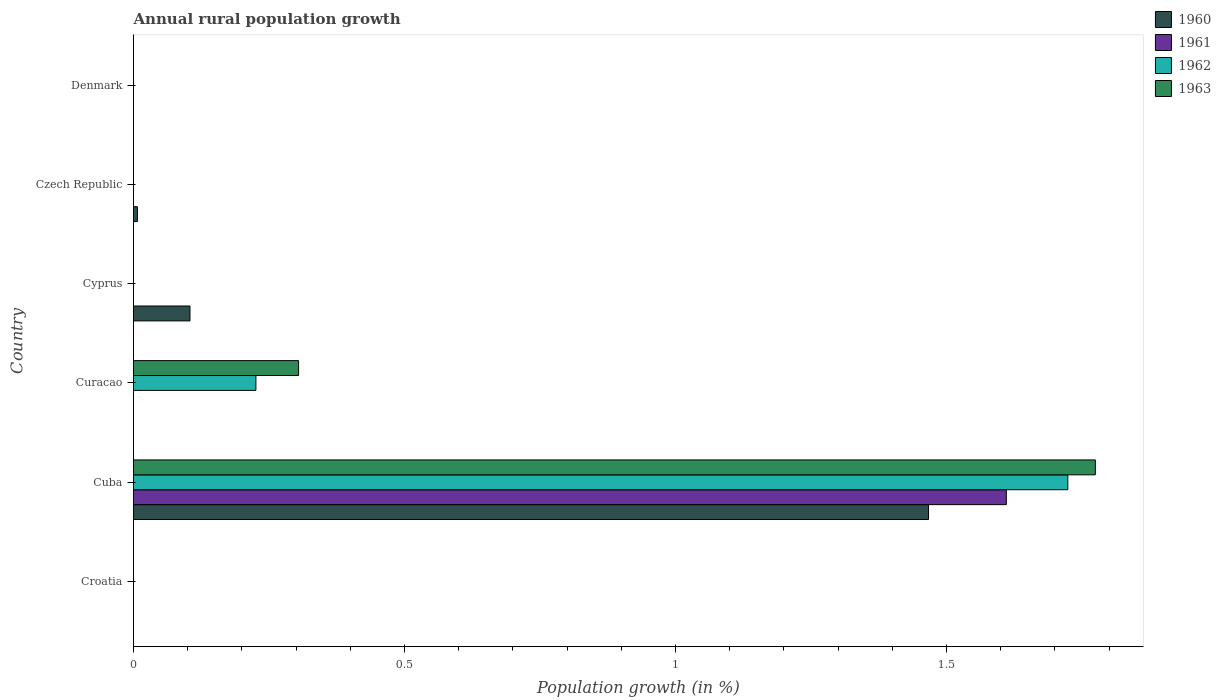How many different coloured bars are there?
Give a very brief answer. 4. How many bars are there on the 6th tick from the top?
Give a very brief answer. 0. What is the label of the 1st group of bars from the top?
Offer a terse response. Denmark. Across all countries, what is the maximum percentage of rural population growth in 1962?
Give a very brief answer. 1.72. Across all countries, what is the minimum percentage of rural population growth in 1960?
Your response must be concise. 0. In which country was the percentage of rural population growth in 1960 maximum?
Ensure brevity in your answer.  Cuba. What is the total percentage of rural population growth in 1962 in the graph?
Offer a terse response. 1.95. What is the difference between the percentage of rural population growth in 1961 in Czech Republic and the percentage of rural population growth in 1962 in Cuba?
Provide a succinct answer. -1.72. What is the average percentage of rural population growth in 1960 per country?
Your answer should be compact. 0.26. What is the difference between the percentage of rural population growth in 1962 and percentage of rural population growth in 1961 in Cuba?
Give a very brief answer. 0.11. In how many countries, is the percentage of rural population growth in 1963 greater than 1 %?
Your response must be concise. 1. What is the ratio of the percentage of rural population growth in 1962 in Cuba to that in Curacao?
Your answer should be very brief. 7.63. What is the difference between the highest and the lowest percentage of rural population growth in 1962?
Provide a succinct answer. 1.72. How many countries are there in the graph?
Provide a short and direct response. 6. What is the difference between two consecutive major ticks on the X-axis?
Give a very brief answer. 0.5. Does the graph contain any zero values?
Your answer should be very brief. Yes. Does the graph contain grids?
Your answer should be compact. No. How are the legend labels stacked?
Provide a short and direct response. Vertical. What is the title of the graph?
Your response must be concise. Annual rural population growth. Does "2001" appear as one of the legend labels in the graph?
Your response must be concise. No. What is the label or title of the X-axis?
Provide a short and direct response. Population growth (in %). What is the Population growth (in %) of 1961 in Croatia?
Provide a succinct answer. 0. What is the Population growth (in %) of 1963 in Croatia?
Give a very brief answer. 0. What is the Population growth (in %) of 1960 in Cuba?
Provide a short and direct response. 1.47. What is the Population growth (in %) of 1961 in Cuba?
Your answer should be very brief. 1.61. What is the Population growth (in %) of 1962 in Cuba?
Offer a very short reply. 1.72. What is the Population growth (in %) in 1963 in Cuba?
Ensure brevity in your answer.  1.77. What is the Population growth (in %) in 1961 in Curacao?
Ensure brevity in your answer.  0. What is the Population growth (in %) of 1962 in Curacao?
Offer a very short reply. 0.23. What is the Population growth (in %) of 1963 in Curacao?
Provide a succinct answer. 0.3. What is the Population growth (in %) of 1960 in Cyprus?
Keep it short and to the point. 0.1. What is the Population growth (in %) of 1963 in Cyprus?
Offer a terse response. 0. What is the Population growth (in %) in 1960 in Czech Republic?
Your answer should be compact. 0.01. What is the Population growth (in %) of 1963 in Czech Republic?
Make the answer very short. 0. What is the Population growth (in %) of 1960 in Denmark?
Keep it short and to the point. 0. What is the Population growth (in %) in 1961 in Denmark?
Offer a terse response. 0. What is the Population growth (in %) of 1963 in Denmark?
Make the answer very short. 0. Across all countries, what is the maximum Population growth (in %) of 1960?
Provide a short and direct response. 1.47. Across all countries, what is the maximum Population growth (in %) of 1961?
Offer a very short reply. 1.61. Across all countries, what is the maximum Population growth (in %) of 1962?
Ensure brevity in your answer.  1.72. Across all countries, what is the maximum Population growth (in %) of 1963?
Give a very brief answer. 1.77. Across all countries, what is the minimum Population growth (in %) in 1960?
Your response must be concise. 0. Across all countries, what is the minimum Population growth (in %) in 1961?
Offer a terse response. 0. Across all countries, what is the minimum Population growth (in %) of 1962?
Offer a very short reply. 0. What is the total Population growth (in %) in 1960 in the graph?
Your response must be concise. 1.58. What is the total Population growth (in %) in 1961 in the graph?
Make the answer very short. 1.61. What is the total Population growth (in %) in 1962 in the graph?
Provide a short and direct response. 1.95. What is the total Population growth (in %) in 1963 in the graph?
Ensure brevity in your answer.  2.08. What is the difference between the Population growth (in %) in 1962 in Cuba and that in Curacao?
Make the answer very short. 1.5. What is the difference between the Population growth (in %) of 1963 in Cuba and that in Curacao?
Keep it short and to the point. 1.47. What is the difference between the Population growth (in %) in 1960 in Cuba and that in Cyprus?
Keep it short and to the point. 1.36. What is the difference between the Population growth (in %) in 1960 in Cuba and that in Czech Republic?
Your response must be concise. 1.46. What is the difference between the Population growth (in %) of 1960 in Cyprus and that in Czech Republic?
Offer a terse response. 0.1. What is the difference between the Population growth (in %) of 1960 in Cuba and the Population growth (in %) of 1962 in Curacao?
Provide a succinct answer. 1.24. What is the difference between the Population growth (in %) in 1960 in Cuba and the Population growth (in %) in 1963 in Curacao?
Ensure brevity in your answer.  1.16. What is the difference between the Population growth (in %) of 1961 in Cuba and the Population growth (in %) of 1962 in Curacao?
Keep it short and to the point. 1.38. What is the difference between the Population growth (in %) of 1961 in Cuba and the Population growth (in %) of 1963 in Curacao?
Keep it short and to the point. 1.31. What is the difference between the Population growth (in %) in 1962 in Cuba and the Population growth (in %) in 1963 in Curacao?
Provide a succinct answer. 1.42. What is the average Population growth (in %) in 1960 per country?
Give a very brief answer. 0.26. What is the average Population growth (in %) of 1961 per country?
Your response must be concise. 0.27. What is the average Population growth (in %) in 1962 per country?
Offer a terse response. 0.32. What is the average Population growth (in %) of 1963 per country?
Your response must be concise. 0.35. What is the difference between the Population growth (in %) of 1960 and Population growth (in %) of 1961 in Cuba?
Give a very brief answer. -0.14. What is the difference between the Population growth (in %) of 1960 and Population growth (in %) of 1962 in Cuba?
Your answer should be compact. -0.26. What is the difference between the Population growth (in %) of 1960 and Population growth (in %) of 1963 in Cuba?
Keep it short and to the point. -0.31. What is the difference between the Population growth (in %) of 1961 and Population growth (in %) of 1962 in Cuba?
Offer a very short reply. -0.11. What is the difference between the Population growth (in %) of 1961 and Population growth (in %) of 1963 in Cuba?
Ensure brevity in your answer.  -0.16. What is the difference between the Population growth (in %) of 1962 and Population growth (in %) of 1963 in Cuba?
Provide a succinct answer. -0.05. What is the difference between the Population growth (in %) of 1962 and Population growth (in %) of 1963 in Curacao?
Ensure brevity in your answer.  -0.08. What is the ratio of the Population growth (in %) of 1962 in Cuba to that in Curacao?
Make the answer very short. 7.63. What is the ratio of the Population growth (in %) of 1963 in Cuba to that in Curacao?
Your answer should be very brief. 5.83. What is the ratio of the Population growth (in %) of 1960 in Cuba to that in Cyprus?
Provide a short and direct response. 14.08. What is the ratio of the Population growth (in %) of 1960 in Cuba to that in Czech Republic?
Give a very brief answer. 202.03. What is the ratio of the Population growth (in %) in 1960 in Cyprus to that in Czech Republic?
Ensure brevity in your answer.  14.35. What is the difference between the highest and the second highest Population growth (in %) in 1960?
Your answer should be compact. 1.36. What is the difference between the highest and the lowest Population growth (in %) in 1960?
Provide a short and direct response. 1.47. What is the difference between the highest and the lowest Population growth (in %) of 1961?
Offer a terse response. 1.61. What is the difference between the highest and the lowest Population growth (in %) of 1962?
Offer a terse response. 1.72. What is the difference between the highest and the lowest Population growth (in %) in 1963?
Offer a very short reply. 1.77. 